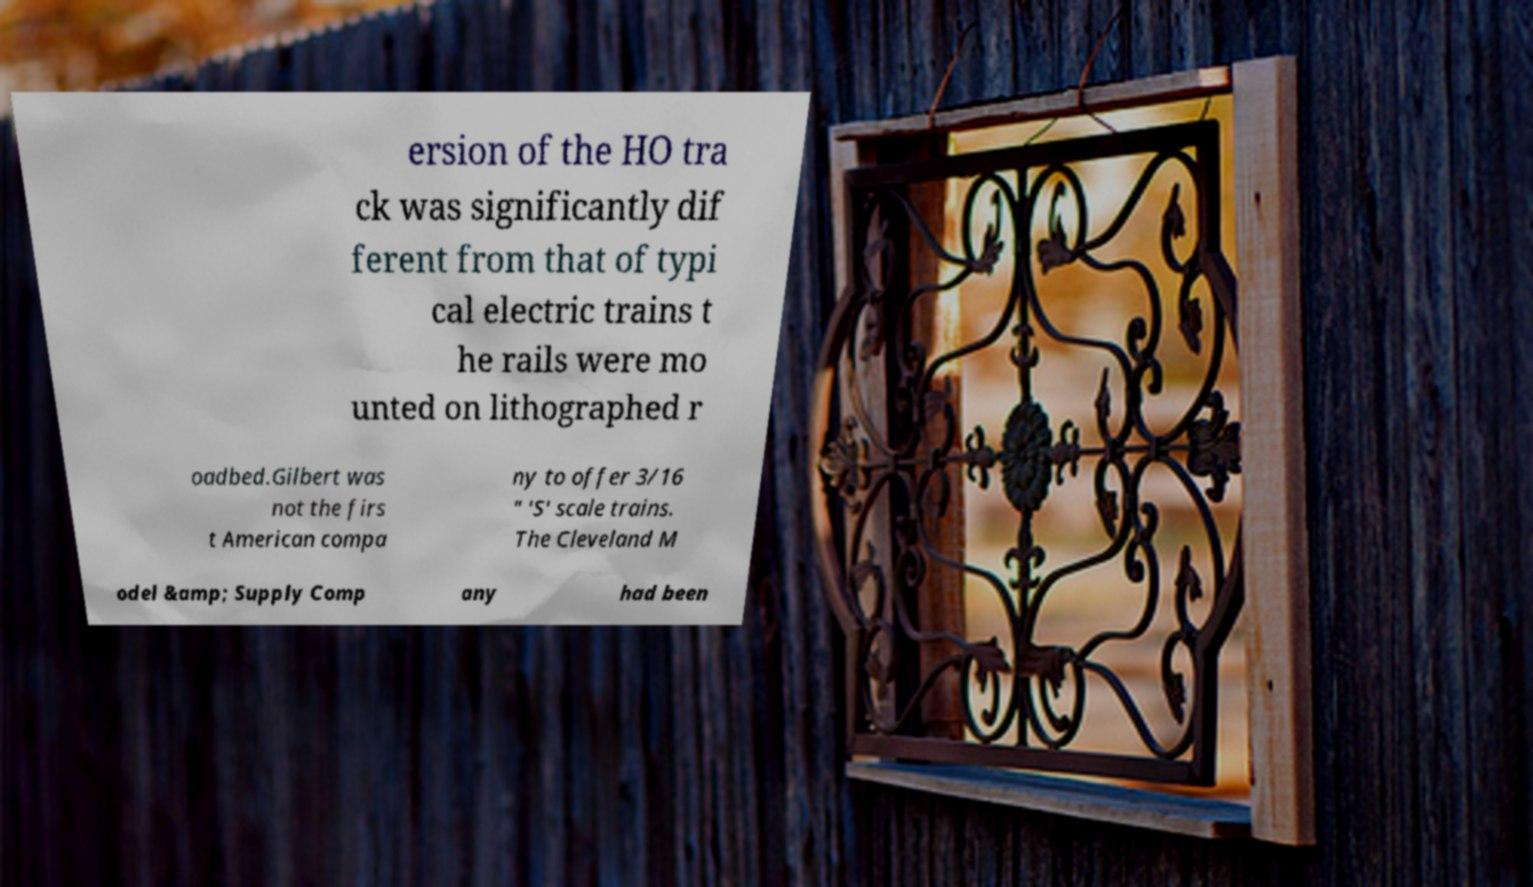For documentation purposes, I need the text within this image transcribed. Could you provide that? ersion of the HO tra ck was significantly dif ferent from that of typi cal electric trains t he rails were mo unted on lithographed r oadbed.Gilbert was not the firs t American compa ny to offer 3/16 " 'S' scale trains. The Cleveland M odel &amp; Supply Comp any had been 